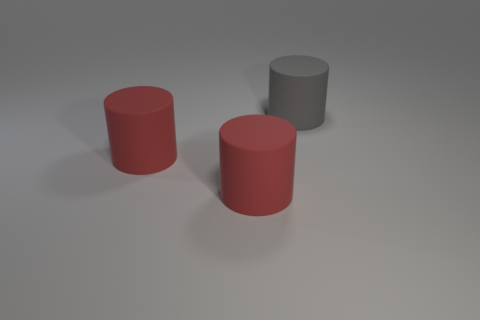Are there more large red rubber things that are to the right of the gray rubber cylinder than large gray rubber cylinders?
Provide a succinct answer. No. What is the size of the gray cylinder?
Provide a succinct answer. Large. There is a big gray cylinder; are there any gray rubber cylinders on the left side of it?
Keep it short and to the point. No. Are there any green shiny objects of the same size as the gray matte cylinder?
Make the answer very short. No. What material is the big gray thing?
Give a very brief answer. Rubber. What shape is the gray thing?
Make the answer very short. Cylinder. How many brown things are either big objects or matte spheres?
Your response must be concise. 0. How many tiny things are either yellow blocks or red cylinders?
Provide a succinct answer. 0. What number of rubber things are either small red objects or red things?
Your answer should be compact. 2. Is there anything else that has the same shape as the big gray matte thing?
Give a very brief answer. Yes. 